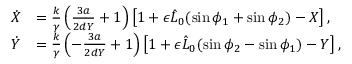<formula> <loc_0><loc_0><loc_500><loc_500>\begin{array} { r l } { \dot { X } } & { = \frac { k } { \gamma } \left ( \frac { 3 a } { 2 d Y } + 1 \right ) \left [ 1 + \epsilon \hat { L } _ { 0 } ( \sin { \phi _ { 1 } } + \sin { \phi _ { 2 } } ) - X \right ] , } \\ { \dot { Y } } & { = \frac { k } { \gamma } \left ( - \frac { 3 a } { 2 d Y } + 1 \right ) \left [ 1 + \epsilon \hat { L } _ { 0 } ( \sin { \phi _ { 2 } } - \sin { \phi _ { 1 } } ) - Y \right ] , } \end{array}</formula> 